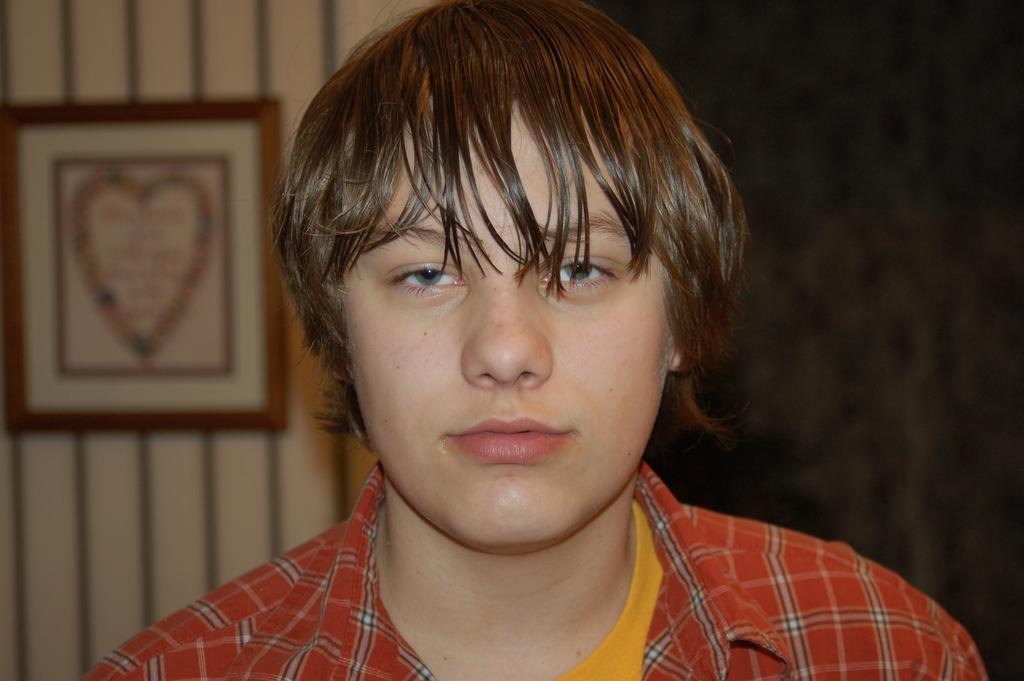How would you summarize this image in a sentence or two? In this image we can see a person wearing red color shirt and yellow color t-shirt. The background of the image is slightly blurred, where we can see a photo frame on the wall and this part of the image is dark. 